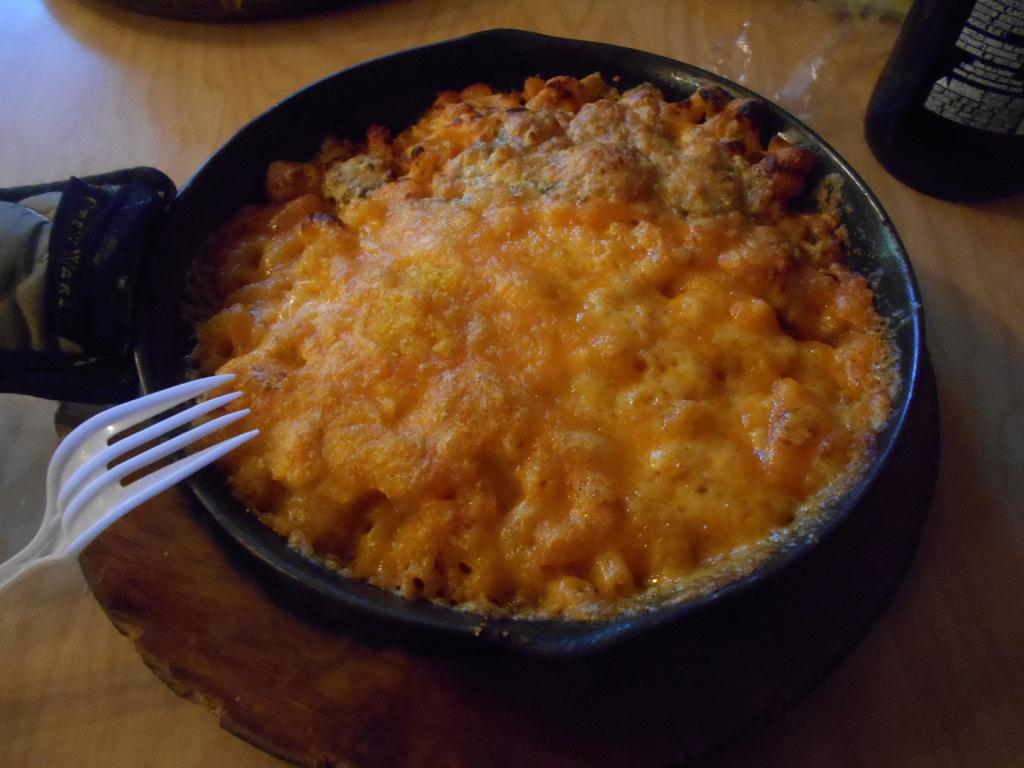What is in the pan that is visible in the image? There is a pan with food items in the image. Where is the pan located in the image? The pan is placed on a table in the image. What utensil is visible on the left side of the image? There is a fork on the left side of the image. What is located in the top right-hand corner of the image? There is a bottle in the top right-hand corner of the image. What is the price of the governor in the image? There is no governor present in the image, and therefore no price can be determined. 